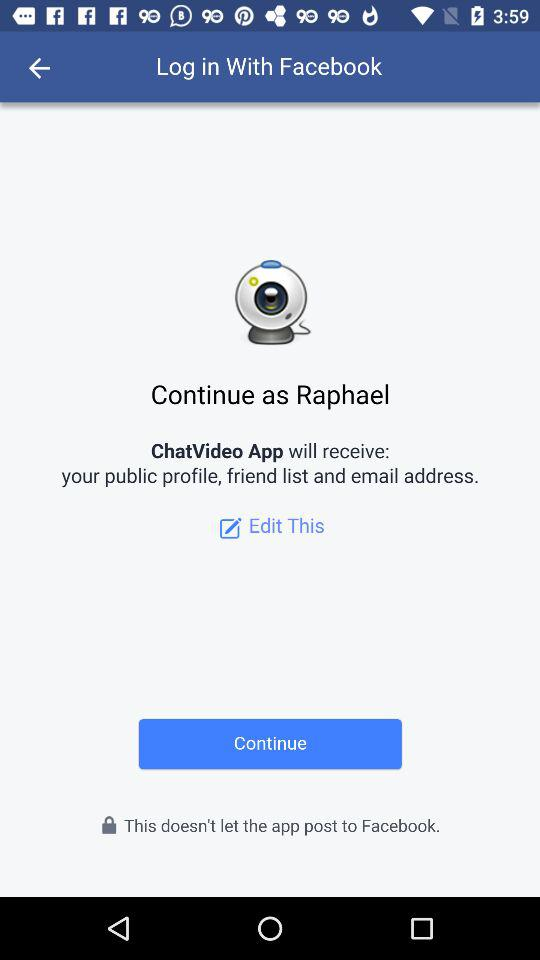How many profile information is ChatVideo App allowed to receive?
Answer the question using a single word or phrase. 3 